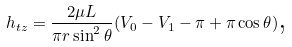Convert formula to latex. <formula><loc_0><loc_0><loc_500><loc_500>h _ { t z } = \frac { 2 \mu L } { \pi r \sin ^ { 2 } \theta } ( V _ { 0 } - V _ { 1 } - \pi + \pi \cos \theta ) \text {,}</formula> 